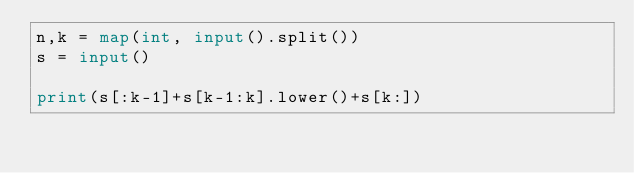<code> <loc_0><loc_0><loc_500><loc_500><_Python_>n,k = map(int, input().split())
s = input()

print(s[:k-1]+s[k-1:k].lower()+s[k:])
</code> 